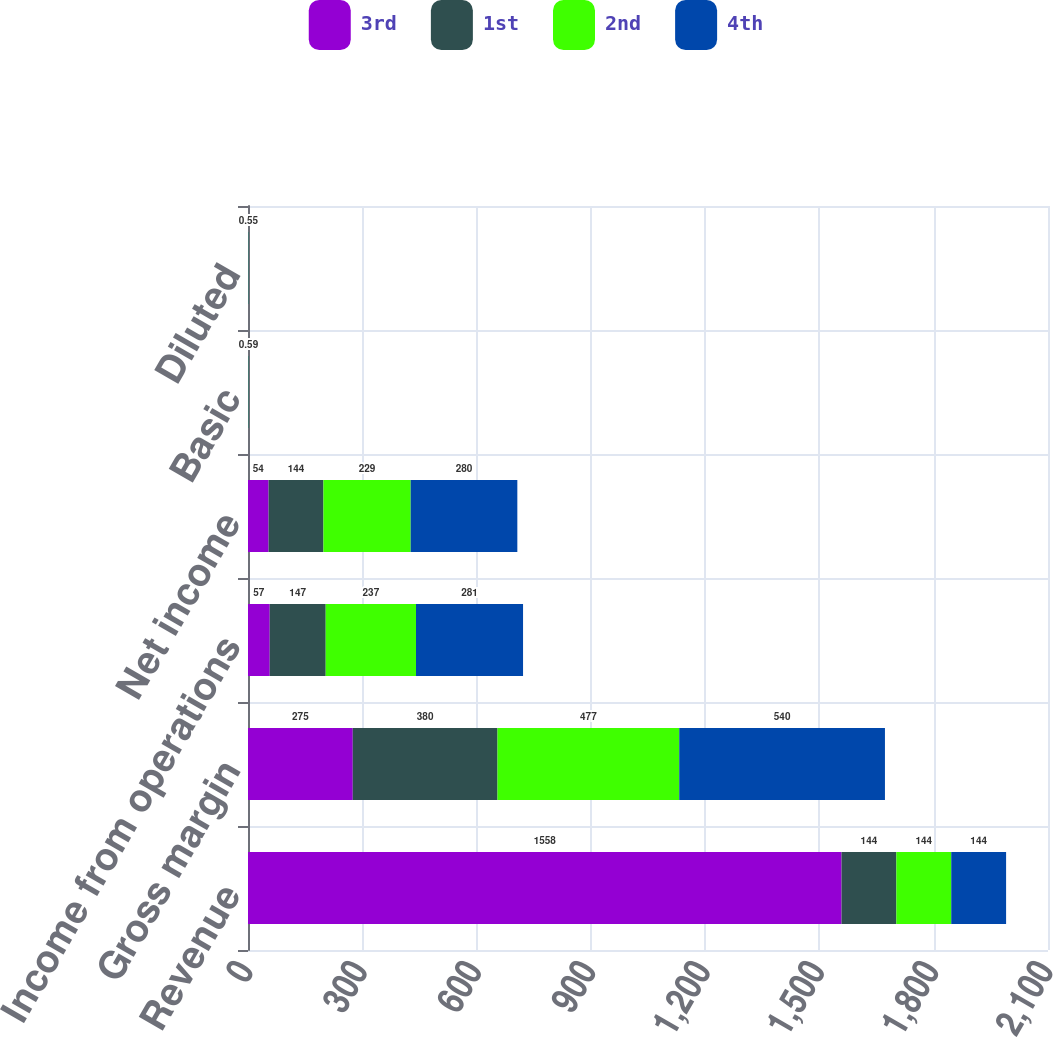Convert chart to OTSL. <chart><loc_0><loc_0><loc_500><loc_500><stacked_bar_chart><ecel><fcel>Revenue<fcel>Gross margin<fcel>Income from operations<fcel>Net income<fcel>Basic<fcel>Diluted<nl><fcel>3rd<fcel>1558<fcel>275<fcel>57<fcel>54<fcel>0.12<fcel>0.11<nl><fcel>1st<fcel>144<fcel>380<fcel>147<fcel>144<fcel>0.31<fcel>0.29<nl><fcel>2nd<fcel>144<fcel>477<fcel>237<fcel>229<fcel>0.49<fcel>0.45<nl><fcel>4th<fcel>144<fcel>540<fcel>281<fcel>280<fcel>0.59<fcel>0.55<nl></chart> 